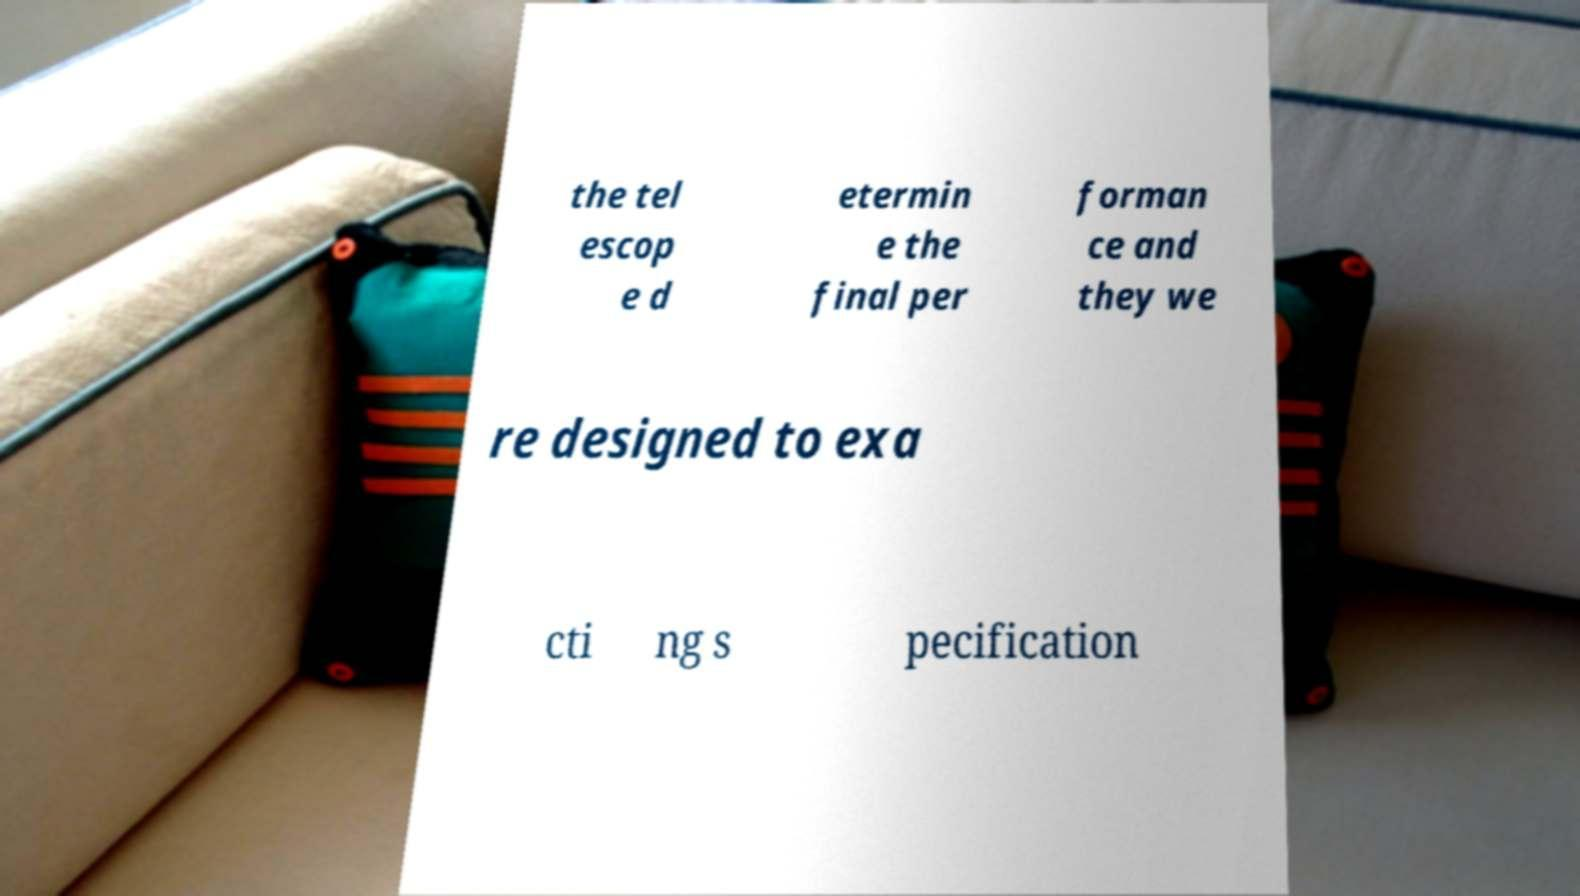Can you read and provide the text displayed in the image?This photo seems to have some interesting text. Can you extract and type it out for me? the tel escop e d etermin e the final per forman ce and they we re designed to exa cti ng s pecification 